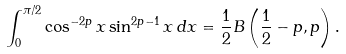Convert formula to latex. <formula><loc_0><loc_0><loc_500><loc_500>\int _ { 0 } ^ { \pi / 2 } \cos ^ { - 2 p } x \sin ^ { 2 p - 1 } x \, d x = \frac { 1 } { 2 } B \left ( \frac { 1 } { 2 } - p , p \right ) .</formula> 